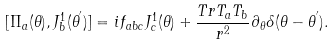<formula> <loc_0><loc_0><loc_500><loc_500>[ \Pi _ { a } ( \theta ) , J _ { b } ^ { 1 } ( \theta ^ { ^ { \prime } } ) ] = i f _ { a b c } J _ { c } ^ { 1 } ( \theta ) + \frac { T r T _ { a } T _ { b } } { r ^ { 2 } } \partial _ { \theta } \delta ( \theta - \theta ^ { ^ { \prime } } ) .</formula> 